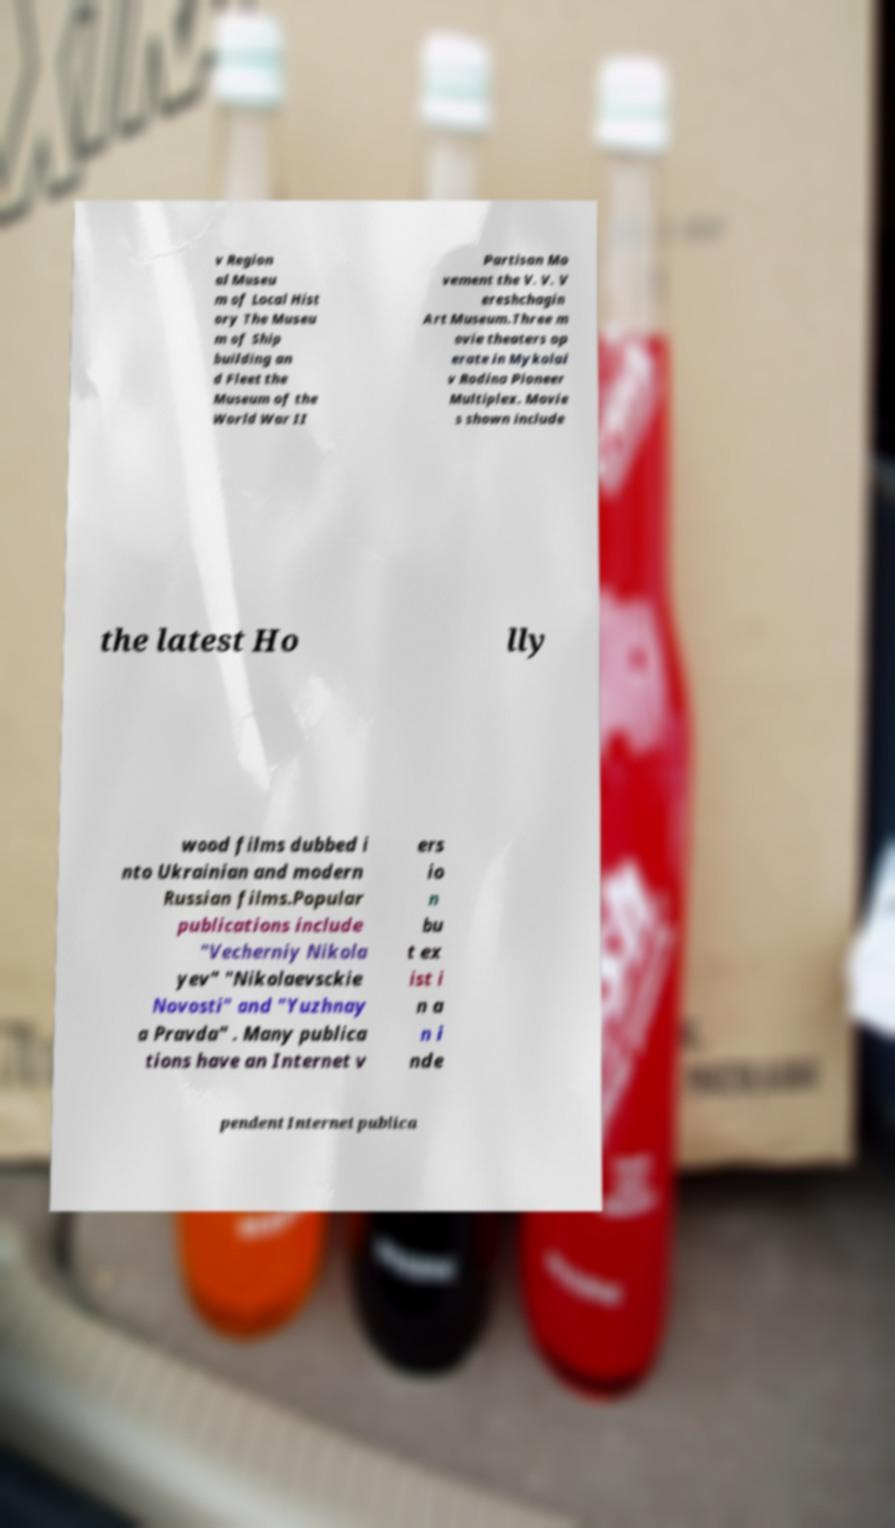What messages or text are displayed in this image? I need them in a readable, typed format. v Region al Museu m of Local Hist ory The Museu m of Ship building an d Fleet the Museum of the World War II Partisan Mo vement the V. V. V ereshchagin Art Museum.Three m ovie theaters op erate in Mykolai v Rodina Pioneer Multiplex. Movie s shown include the latest Ho lly wood films dubbed i nto Ukrainian and modern Russian films.Popular publications include "Vecherniy Nikola yev" "Nikolaevsckie Novosti" and "Yuzhnay a Pravda" . Many publica tions have an Internet v ers io n bu t ex ist i n a n i nde pendent Internet publica 